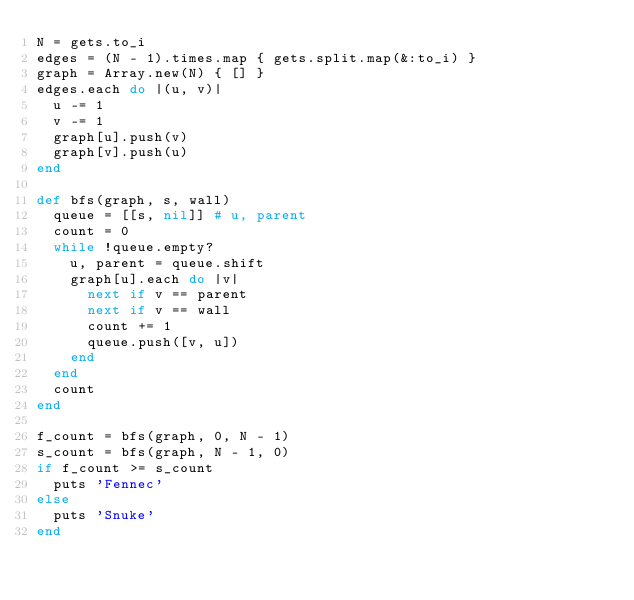<code> <loc_0><loc_0><loc_500><loc_500><_Ruby_>N = gets.to_i
edges = (N - 1).times.map { gets.split.map(&:to_i) }
graph = Array.new(N) { [] }
edges.each do |(u, v)|
  u -= 1
  v -= 1
  graph[u].push(v)
  graph[v].push(u)
end

def bfs(graph, s, wall)
  queue = [[s, nil]] # u, parent
  count = 0
  while !queue.empty?
    u, parent = queue.shift
    graph[u].each do |v|
      next if v == parent
      next if v == wall
      count += 1
      queue.push([v, u])
    end
  end
  count
end

f_count = bfs(graph, 0, N - 1)
s_count = bfs(graph, N - 1, 0)
if f_count >= s_count
  puts 'Fennec'
else
  puts 'Snuke'
end
</code> 